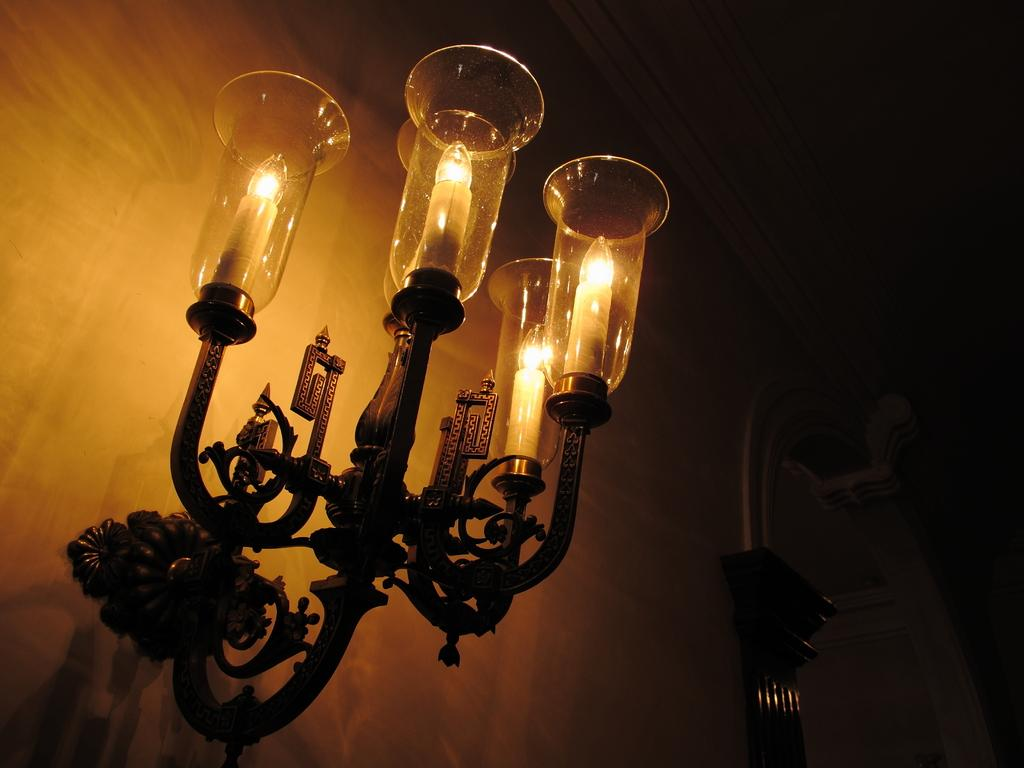What objects can be seen on the left side of the image? There are lamps on the left side of the image. What type of chairs are depicted in the image? There are no chairs present in the image; it only features lamps on the left side. What color is the zephyr in the image? There is no zephyr present in the image, as a zephyr refers to a gentle breeze and is not a physical object that can be depicted in an image. 